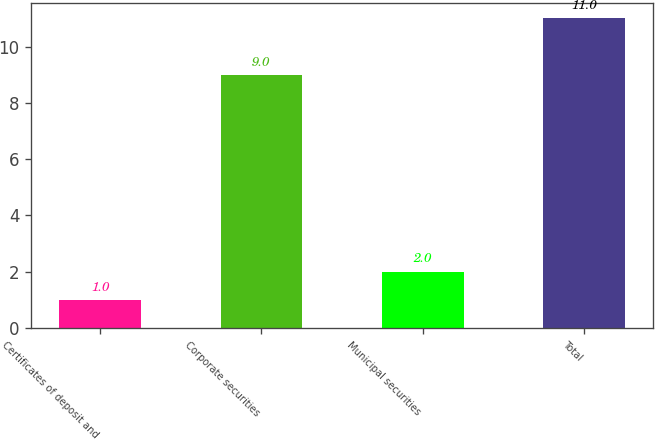Convert chart. <chart><loc_0><loc_0><loc_500><loc_500><bar_chart><fcel>Certificates of deposit and<fcel>Corporate securities<fcel>Municipal securities<fcel>Total<nl><fcel>1<fcel>9<fcel>2<fcel>11<nl></chart> 